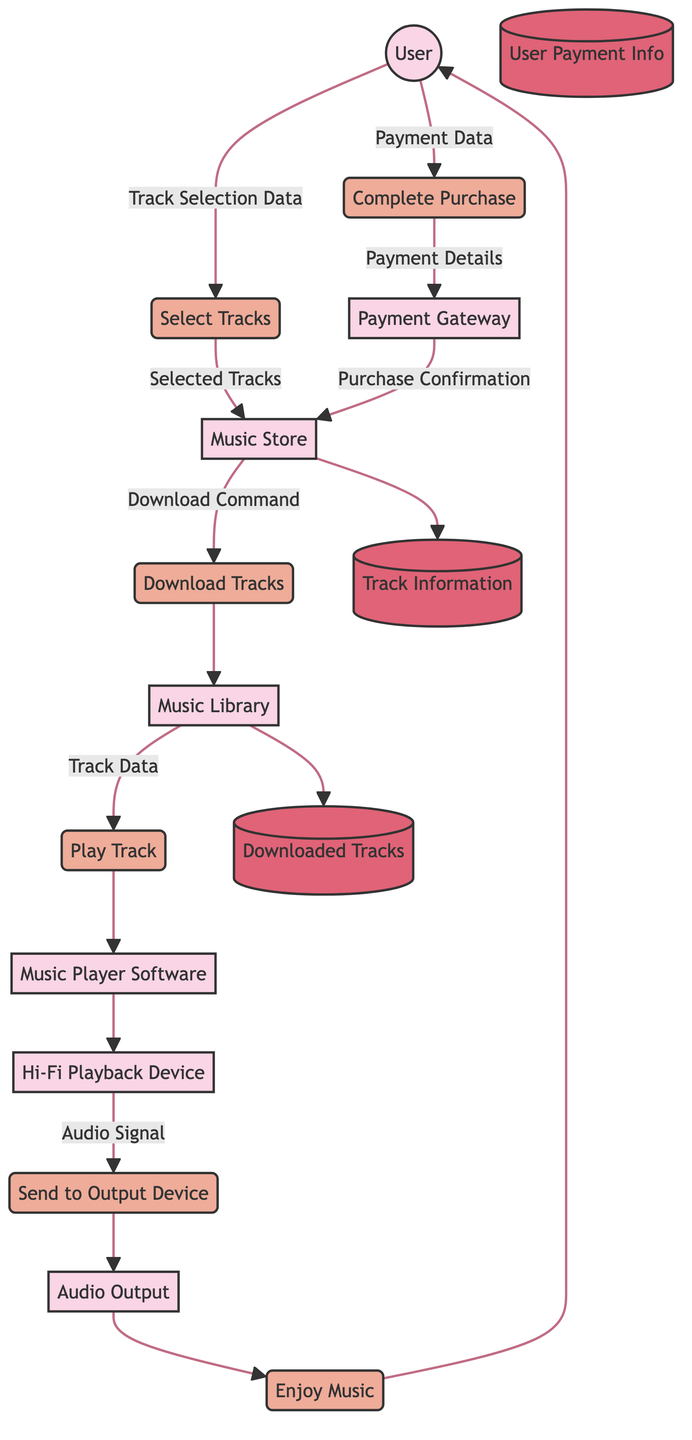What's the total number of entities in the diagram? The diagram identifies six distinct entities: User, Music Store, Payment Gateway, Music Library, Hi-Fi Playback Device, and Music Player Software. Counting these gives a total of six.
Answer: 6 What is the process after the "Complete Purchase" step? After the user completes the purchase, the next step in the flow is "Download Tracks," where the purchased music tracks are downloaded into the user's music library.
Answer: Download Tracks Which data flow comes from the Music Store? The data flow that originates from the Music Store is "Download Command," which sends the command or link to download the purchased tracks to the user.
Answer: Download Command How many data stores are in the diagram? The diagram features three data stores: Track Information, User Payment Info, and Downloaded Tracks. Counting these yields a total of three data stores.
Answer: 3 What does the "Audio Signal" flow from, and to which entity does it go? The "Audio Signal" flows from the Hi-Fi Playback Device to the Audio Output, where the processed audio signal is sent for listening.
Answer: Audio Output What triggers the "Enjoy Music" process? The "Enjoy Music" process is triggered after the audio signal is sent to the audio output, allowing the user to listen to the high-fidelity audio output through speakers or headphones.
Answer: Send to Output Device How is the user’s payment information handled in the process? The user's payment information goes from the User entity to the Payment Gateway as "Payment Data," which is processed to confirm the purchase before allowing the download of tracks.
Answer: Payment Data Which entity retrieves the track data for playback? The music player software retrieves the track data from the Music Library when the user selects a track for playback.
Answer: Music Player Software 